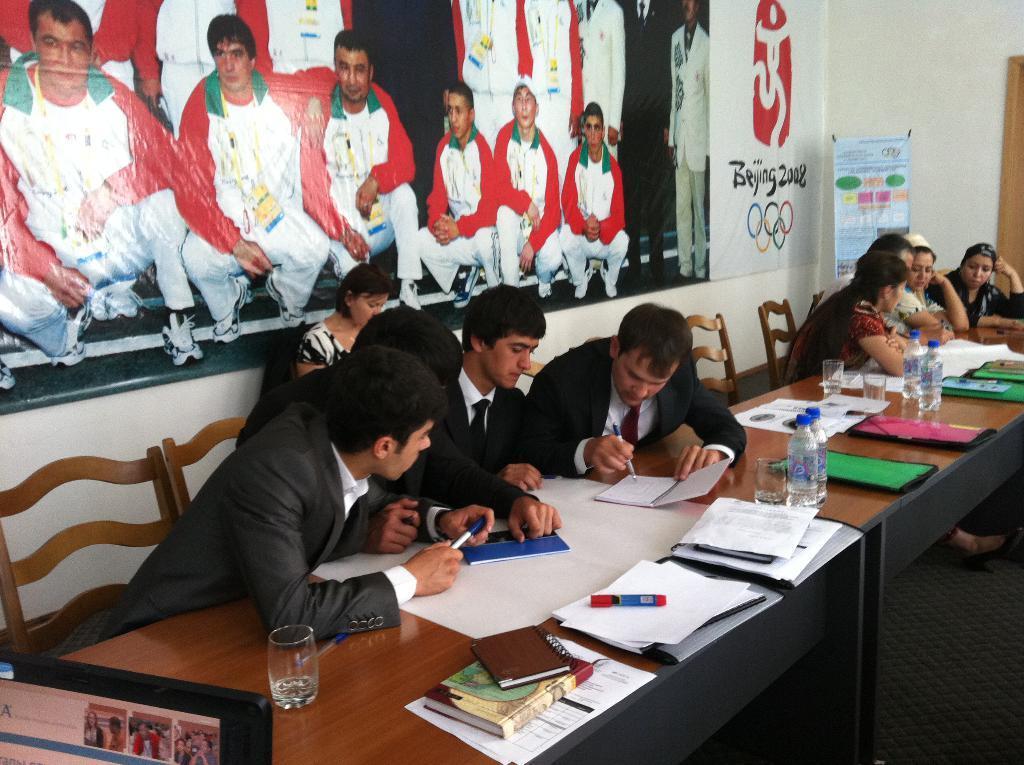In one or two sentences, can you explain what this image depicts? In this picture I can observe some people sitting in the chairs in front of a table on which I can observe water bottles, glasses, papers, books and markers. There are men and women in this picture. On the left side I can observe a poster on the wall. In the background there is a wall. 